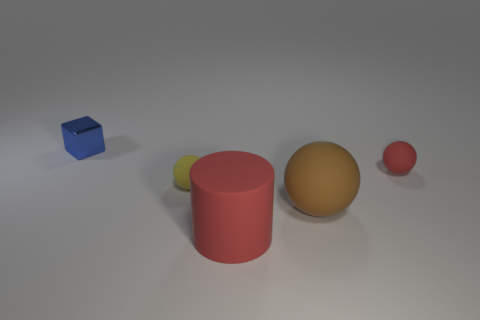What size is the yellow object?
Offer a very short reply. Small. Is there a large sphere that has the same material as the large red cylinder?
Your response must be concise. Yes. What size is the yellow thing that is the same shape as the large brown matte thing?
Your response must be concise. Small. Is the number of matte cylinders that are behind the blue cube the same as the number of large red cylinders?
Your response must be concise. No. Is the shape of the red matte thing that is in front of the brown matte ball the same as  the small shiny thing?
Your response must be concise. No. The metal object is what shape?
Keep it short and to the point. Cube. There is a small thing in front of the tiny sphere to the right of the tiny ball on the left side of the red cylinder; what is its material?
Offer a terse response. Rubber. There is a tiny ball that is the same color as the rubber cylinder; what material is it?
Your answer should be compact. Rubber. How many objects are either blue metallic objects or small objects?
Offer a terse response. 3. Is the material of the small sphere left of the big brown object the same as the large brown sphere?
Offer a terse response. Yes. 